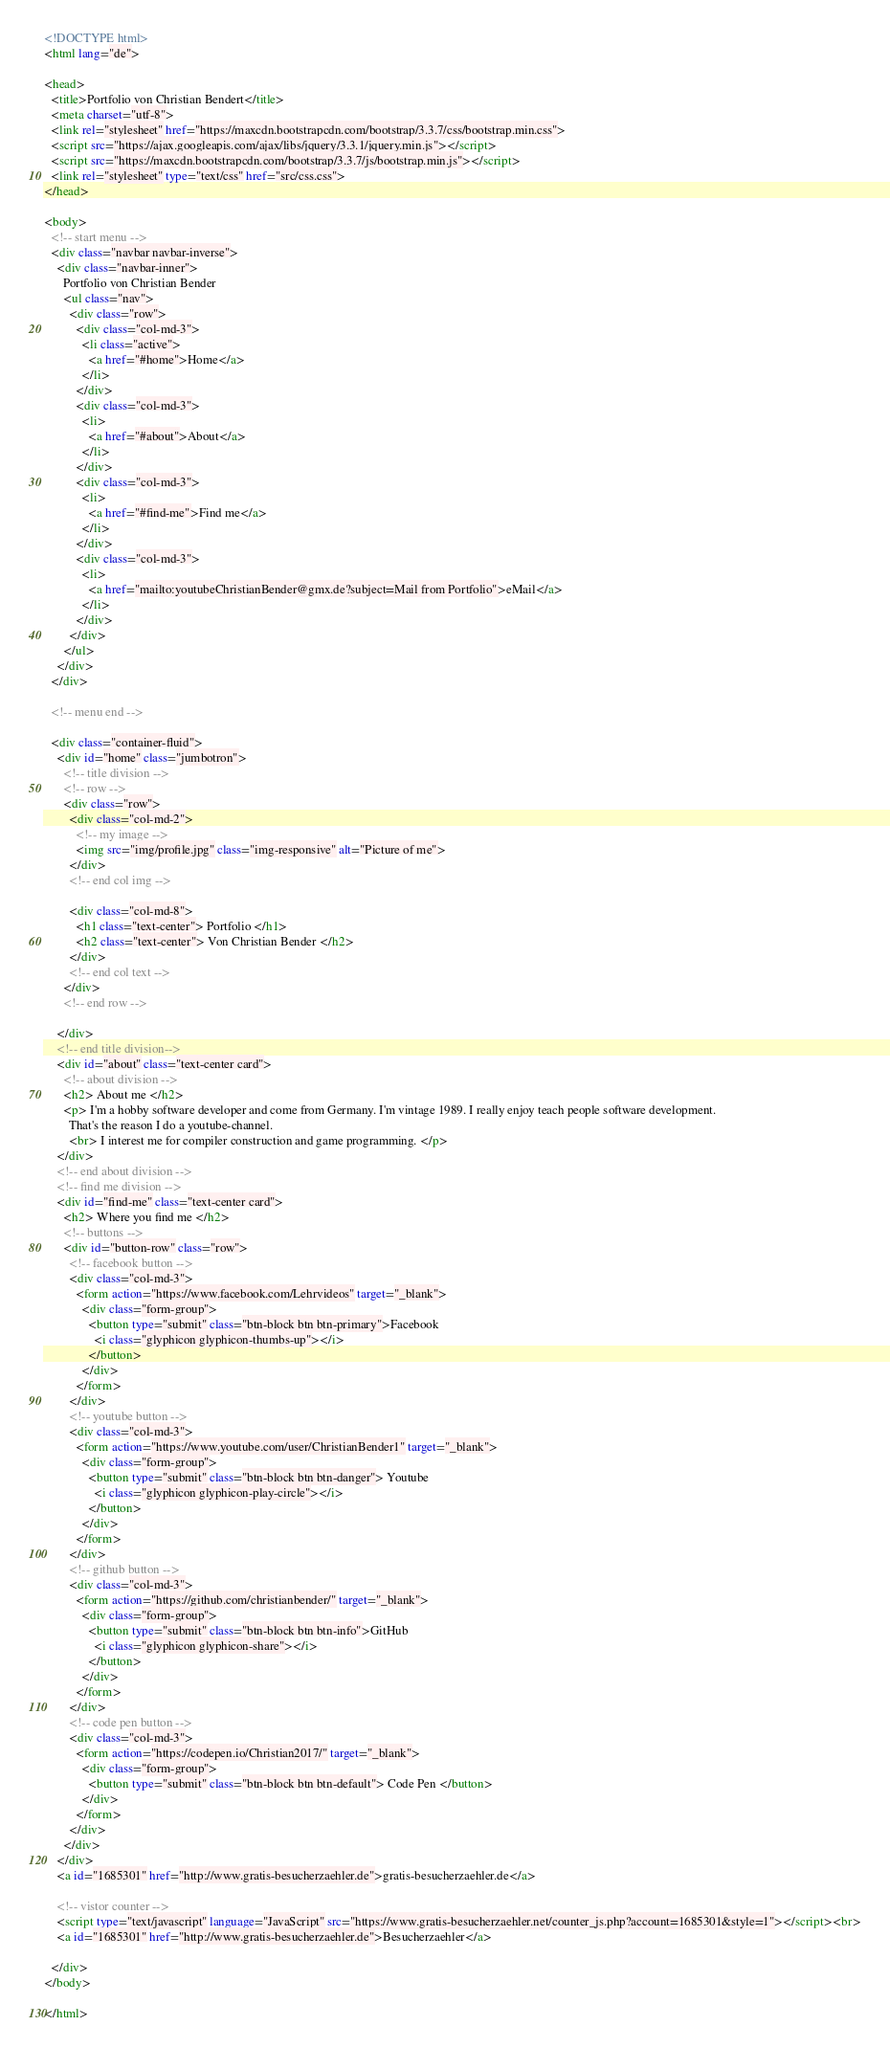Convert code to text. <code><loc_0><loc_0><loc_500><loc_500><_HTML_><!DOCTYPE html>
<html lang="de">

<head>
  <title>Portfolio von Christian Bendert</title>
  <meta charset="utf-8">
  <link rel="stylesheet" href="https://maxcdn.bootstrapcdn.com/bootstrap/3.3.7/css/bootstrap.min.css">
  <script src="https://ajax.googleapis.com/ajax/libs/jquery/3.3.1/jquery.min.js"></script>
  <script src="https://maxcdn.bootstrapcdn.com/bootstrap/3.3.7/js/bootstrap.min.js"></script>
  <link rel="stylesheet" type="text/css" href="src/css.css">
</head>

<body>
  <!-- start menu -->
  <div class="navbar navbar-inverse">
    <div class="navbar-inner">
      Portfolio von Christian Bender
      <ul class="nav">
        <div class="row">
          <div class="col-md-3">
            <li class="active">
              <a href="#home">Home</a>
            </li>
          </div>
          <div class="col-md-3">
            <li>
              <a href="#about">About</a>
            </li>
          </div>
          <div class="col-md-3">
            <li>
              <a href="#find-me">Find me</a>
            </li>
          </div>
          <div class="col-md-3">
            <li>
              <a href="mailto:youtubeChristianBender@gmx.de?subject=Mail from Portfolio">eMail</a>
            </li>
          </div>
        </div>
      </ul>
    </div>
  </div>

  <!-- menu end -->

  <div class="container-fluid">
    <div id="home" class="jumbotron">
      <!-- title division -->
      <!-- row -->
      <div class="row">
        <div class="col-md-2">
          <!-- my image -->
          <img src="img/profile.jpg" class="img-responsive" alt="Picture of me">
        </div>
        <!-- end col img -->

        <div class="col-md-8">
          <h1 class="text-center"> Portfolio </h1>
          <h2 class="text-center"> Von Christian Bender </h2>
        </div>
        <!-- end col text -->
      </div>
      <!-- end row -->

    </div>
    <!-- end title division-->
    <div id="about" class="text-center card">
      <!-- about division -->
      <h2> About me </h2>
      <p> I'm a hobby software developer and come from Germany. I'm vintage 1989. I really enjoy teach people software development.
        That's the reason I do a youtube-channel.
        <br> I interest me for compiler construction and game programming. </p>
    </div>
    <!-- end about division -->
    <!-- find me division -->
    <div id="find-me" class="text-center card">
      <h2> Where you find me </h2>
      <!-- buttons -->
      <div id="button-row" class="row">
        <!-- facebook button -->
        <div class="col-md-3">
          <form action="https://www.facebook.com/Lehrvideos" target="_blank">
            <div class="form-group">
              <button type="submit" class="btn-block btn btn-primary">Facebook
                <i class="glyphicon glyphicon-thumbs-up"></i>
              </button>
            </div>
          </form>
        </div>
        <!-- youtube button -->
        <div class="col-md-3">
          <form action="https://www.youtube.com/user/ChristianBender1" target="_blank">
            <div class="form-group">
              <button type="submit" class="btn-block btn btn-danger"> Youtube
                <i class="glyphicon glyphicon-play-circle"></i>
              </button>
            </div>
          </form>
        </div>
        <!-- github button -->
        <div class="col-md-3">
          <form action="https://github.com/christianbender/" target="_blank">
            <div class="form-group">
              <button type="submit" class="btn-block btn btn-info">GitHub
                <i class="glyphicon glyphicon-share"></i>
              </button>
            </div>
          </form>
        </div>
        <!-- code pen button -->
        <div class="col-md-3">
          <form action="https://codepen.io/Christian2017/" target="_blank">
            <div class="form-group">
              <button type="submit" class="btn-block btn btn-default"> Code Pen </button>
            </div>
          </form>
        </div>
      </div>
    </div>
    <a id="1685301" href="http://www.gratis-besucherzaehler.de">gratis-besucherzaehler.de</a>

    <!-- vistor counter -->
    <script type="text/javascript" language="JavaScript" src="https://www.gratis-besucherzaehler.net/counter_js.php?account=1685301&style=1"></script><br>
    <a id="1685301" href="http://www.gratis-besucherzaehler.de">Besucherzaehler</a>
    
  </div>
</body>

</html></code> 